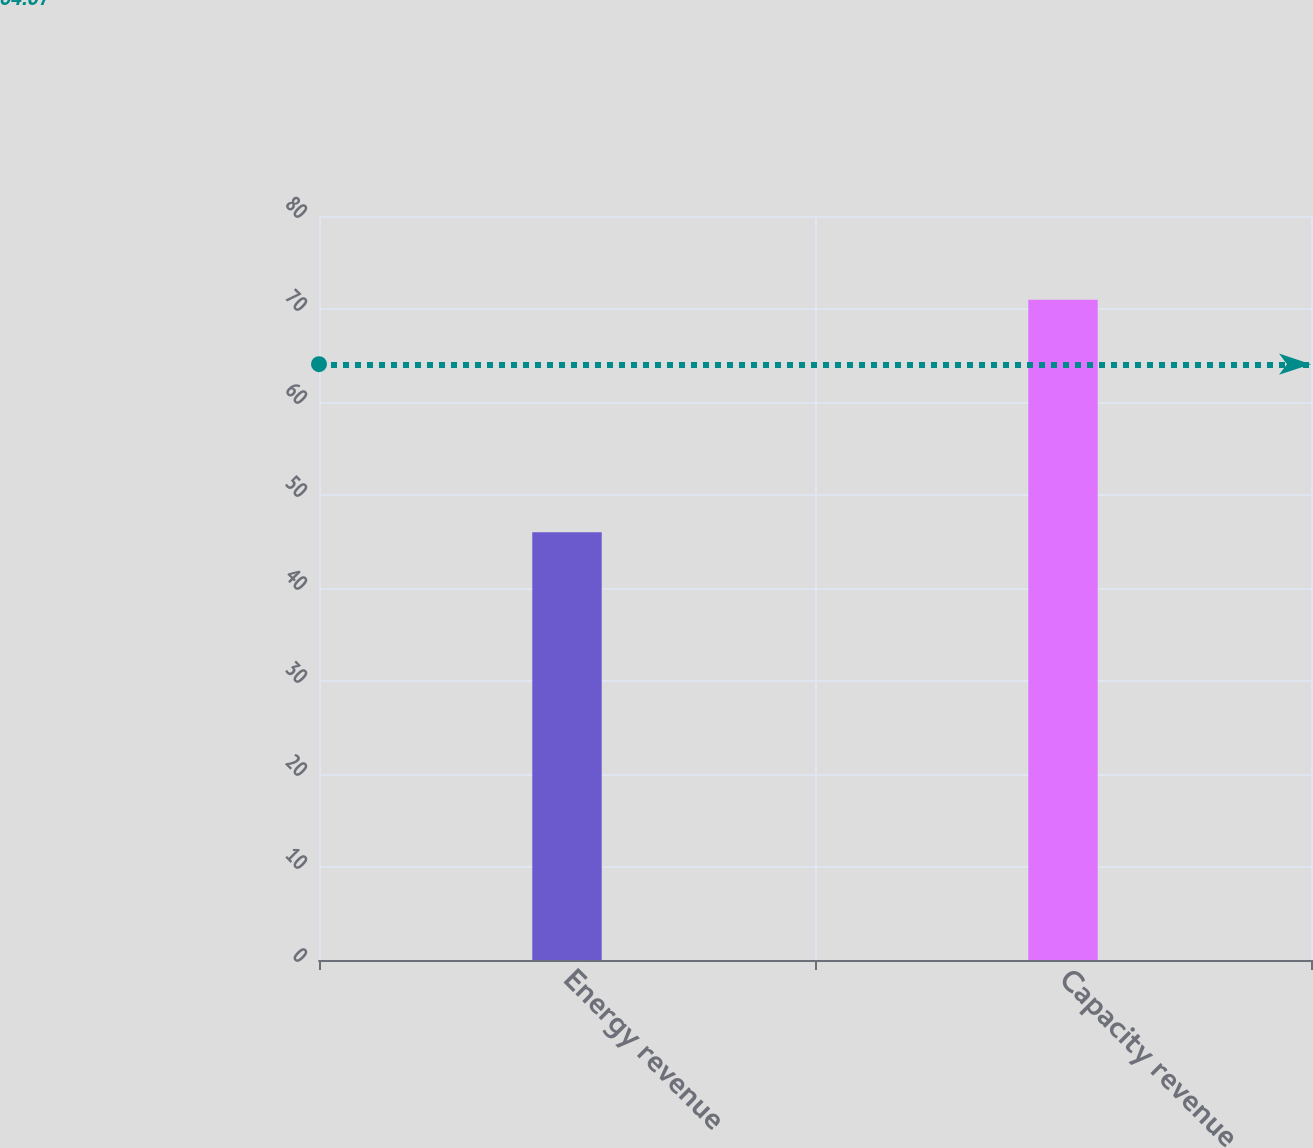<chart> <loc_0><loc_0><loc_500><loc_500><bar_chart><fcel>Energy revenue<fcel>Capacity revenue<nl><fcel>46<fcel>71<nl></chart> 